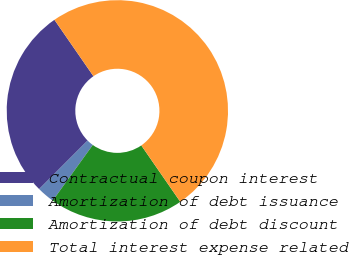Convert chart to OTSL. <chart><loc_0><loc_0><loc_500><loc_500><pie_chart><fcel>Contractual coupon interest<fcel>Amortization of debt issuance<fcel>Amortization of debt discount<fcel>Total interest expense related<nl><fcel>27.88%<fcel>2.56%<fcel>19.56%<fcel>50.0%<nl></chart> 